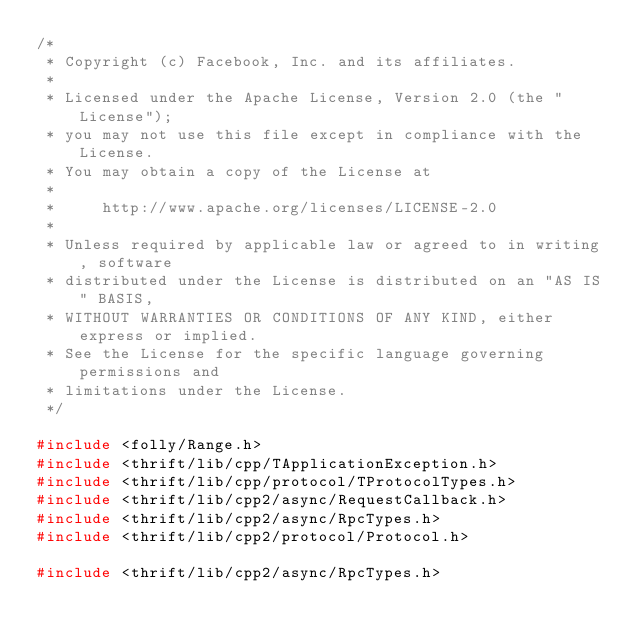<code> <loc_0><loc_0><loc_500><loc_500><_C++_>/*
 * Copyright (c) Facebook, Inc. and its affiliates.
 *
 * Licensed under the Apache License, Version 2.0 (the "License");
 * you may not use this file except in compliance with the License.
 * You may obtain a copy of the License at
 *
 *     http://www.apache.org/licenses/LICENSE-2.0
 *
 * Unless required by applicable law or agreed to in writing, software
 * distributed under the License is distributed on an "AS IS" BASIS,
 * WITHOUT WARRANTIES OR CONDITIONS OF ANY KIND, either express or implied.
 * See the License for the specific language governing permissions and
 * limitations under the License.
 */

#include <folly/Range.h>
#include <thrift/lib/cpp/TApplicationException.h>
#include <thrift/lib/cpp/protocol/TProtocolTypes.h>
#include <thrift/lib/cpp2/async/RequestCallback.h>
#include <thrift/lib/cpp2/async/RpcTypes.h>
#include <thrift/lib/cpp2/protocol/Protocol.h>

#include <thrift/lib/cpp2/async/RpcTypes.h></code> 